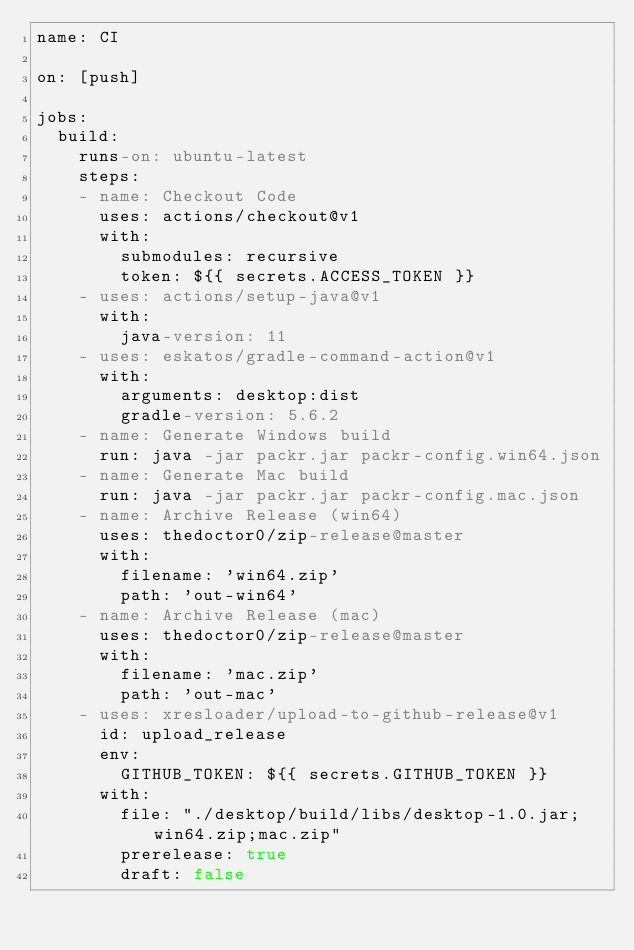Convert code to text. <code><loc_0><loc_0><loc_500><loc_500><_YAML_>name: CI

on: [push]

jobs:
  build:
    runs-on: ubuntu-latest
    steps:
    - name: Checkout Code
      uses: actions/checkout@v1
      with:
        submodules: recursive
        token: ${{ secrets.ACCESS_TOKEN }}
    - uses: actions/setup-java@v1
      with:
        java-version: 11
    - uses: eskatos/gradle-command-action@v1
      with:
        arguments: desktop:dist
        gradle-version: 5.6.2
    - name: Generate Windows build
      run: java -jar packr.jar packr-config.win64.json
    - name: Generate Mac build
      run: java -jar packr.jar packr-config.mac.json
    - name: Archive Release (win64)
      uses: thedoctor0/zip-release@master
      with:
        filename: 'win64.zip'
        path: 'out-win64'
    - name: Archive Release (mac)
      uses: thedoctor0/zip-release@master
      with:
        filename: 'mac.zip'
        path: 'out-mac'
    - uses: xresloader/upload-to-github-release@v1
      id: upload_release
      env:
        GITHUB_TOKEN: ${{ secrets.GITHUB_TOKEN }}
      with:
        file: "./desktop/build/libs/desktop-1.0.jar;win64.zip;mac.zip"
        prerelease: true
        draft: false
</code> 